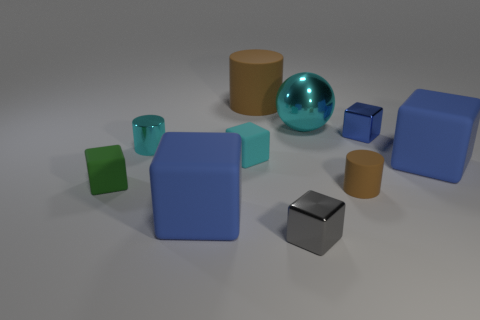How many blue blocks must be subtracted to get 1 blue blocks? 2 Subtract all brown rubber cylinders. How many cylinders are left? 1 Subtract all red cylinders. How many blue blocks are left? 3 Subtract all green blocks. How many blocks are left? 5 Subtract 2 cubes. How many cubes are left? 4 Subtract all brown cubes. Subtract all gray spheres. How many cubes are left? 6 Subtract all cylinders. How many objects are left? 7 Add 5 large purple cubes. How many large purple cubes exist? 5 Subtract 0 brown spheres. How many objects are left? 10 Subtract all big brown matte cylinders. Subtract all big blue matte objects. How many objects are left? 7 